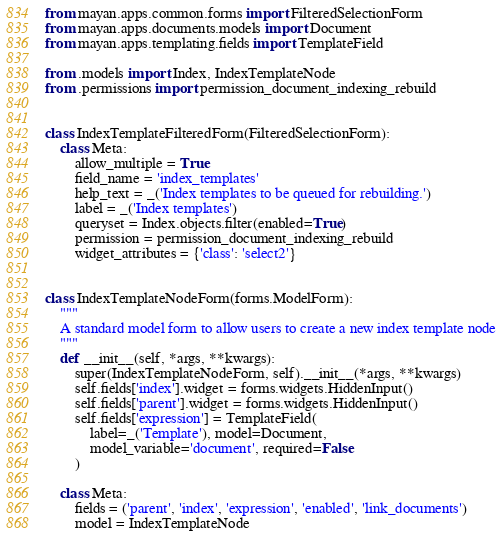Convert code to text. <code><loc_0><loc_0><loc_500><loc_500><_Python_>
from mayan.apps.common.forms import FilteredSelectionForm
from mayan.apps.documents.models import Document
from mayan.apps.templating.fields import TemplateField

from .models import Index, IndexTemplateNode
from .permissions import permission_document_indexing_rebuild


class IndexTemplateFilteredForm(FilteredSelectionForm):
    class Meta:
        allow_multiple = True
        field_name = 'index_templates'
        help_text = _('Index templates to be queued for rebuilding.')
        label = _('Index templates')
        queryset = Index.objects.filter(enabled=True)
        permission = permission_document_indexing_rebuild
        widget_attributes = {'class': 'select2'}


class IndexTemplateNodeForm(forms.ModelForm):
    """
    A standard model form to allow users to create a new index template node
    """
    def __init__(self, *args, **kwargs):
        super(IndexTemplateNodeForm, self).__init__(*args, **kwargs)
        self.fields['index'].widget = forms.widgets.HiddenInput()
        self.fields['parent'].widget = forms.widgets.HiddenInput()
        self.fields['expression'] = TemplateField(
            label=_('Template'), model=Document,
            model_variable='document', required=False
        )

    class Meta:
        fields = ('parent', 'index', 'expression', 'enabled', 'link_documents')
        model = IndexTemplateNode
</code> 